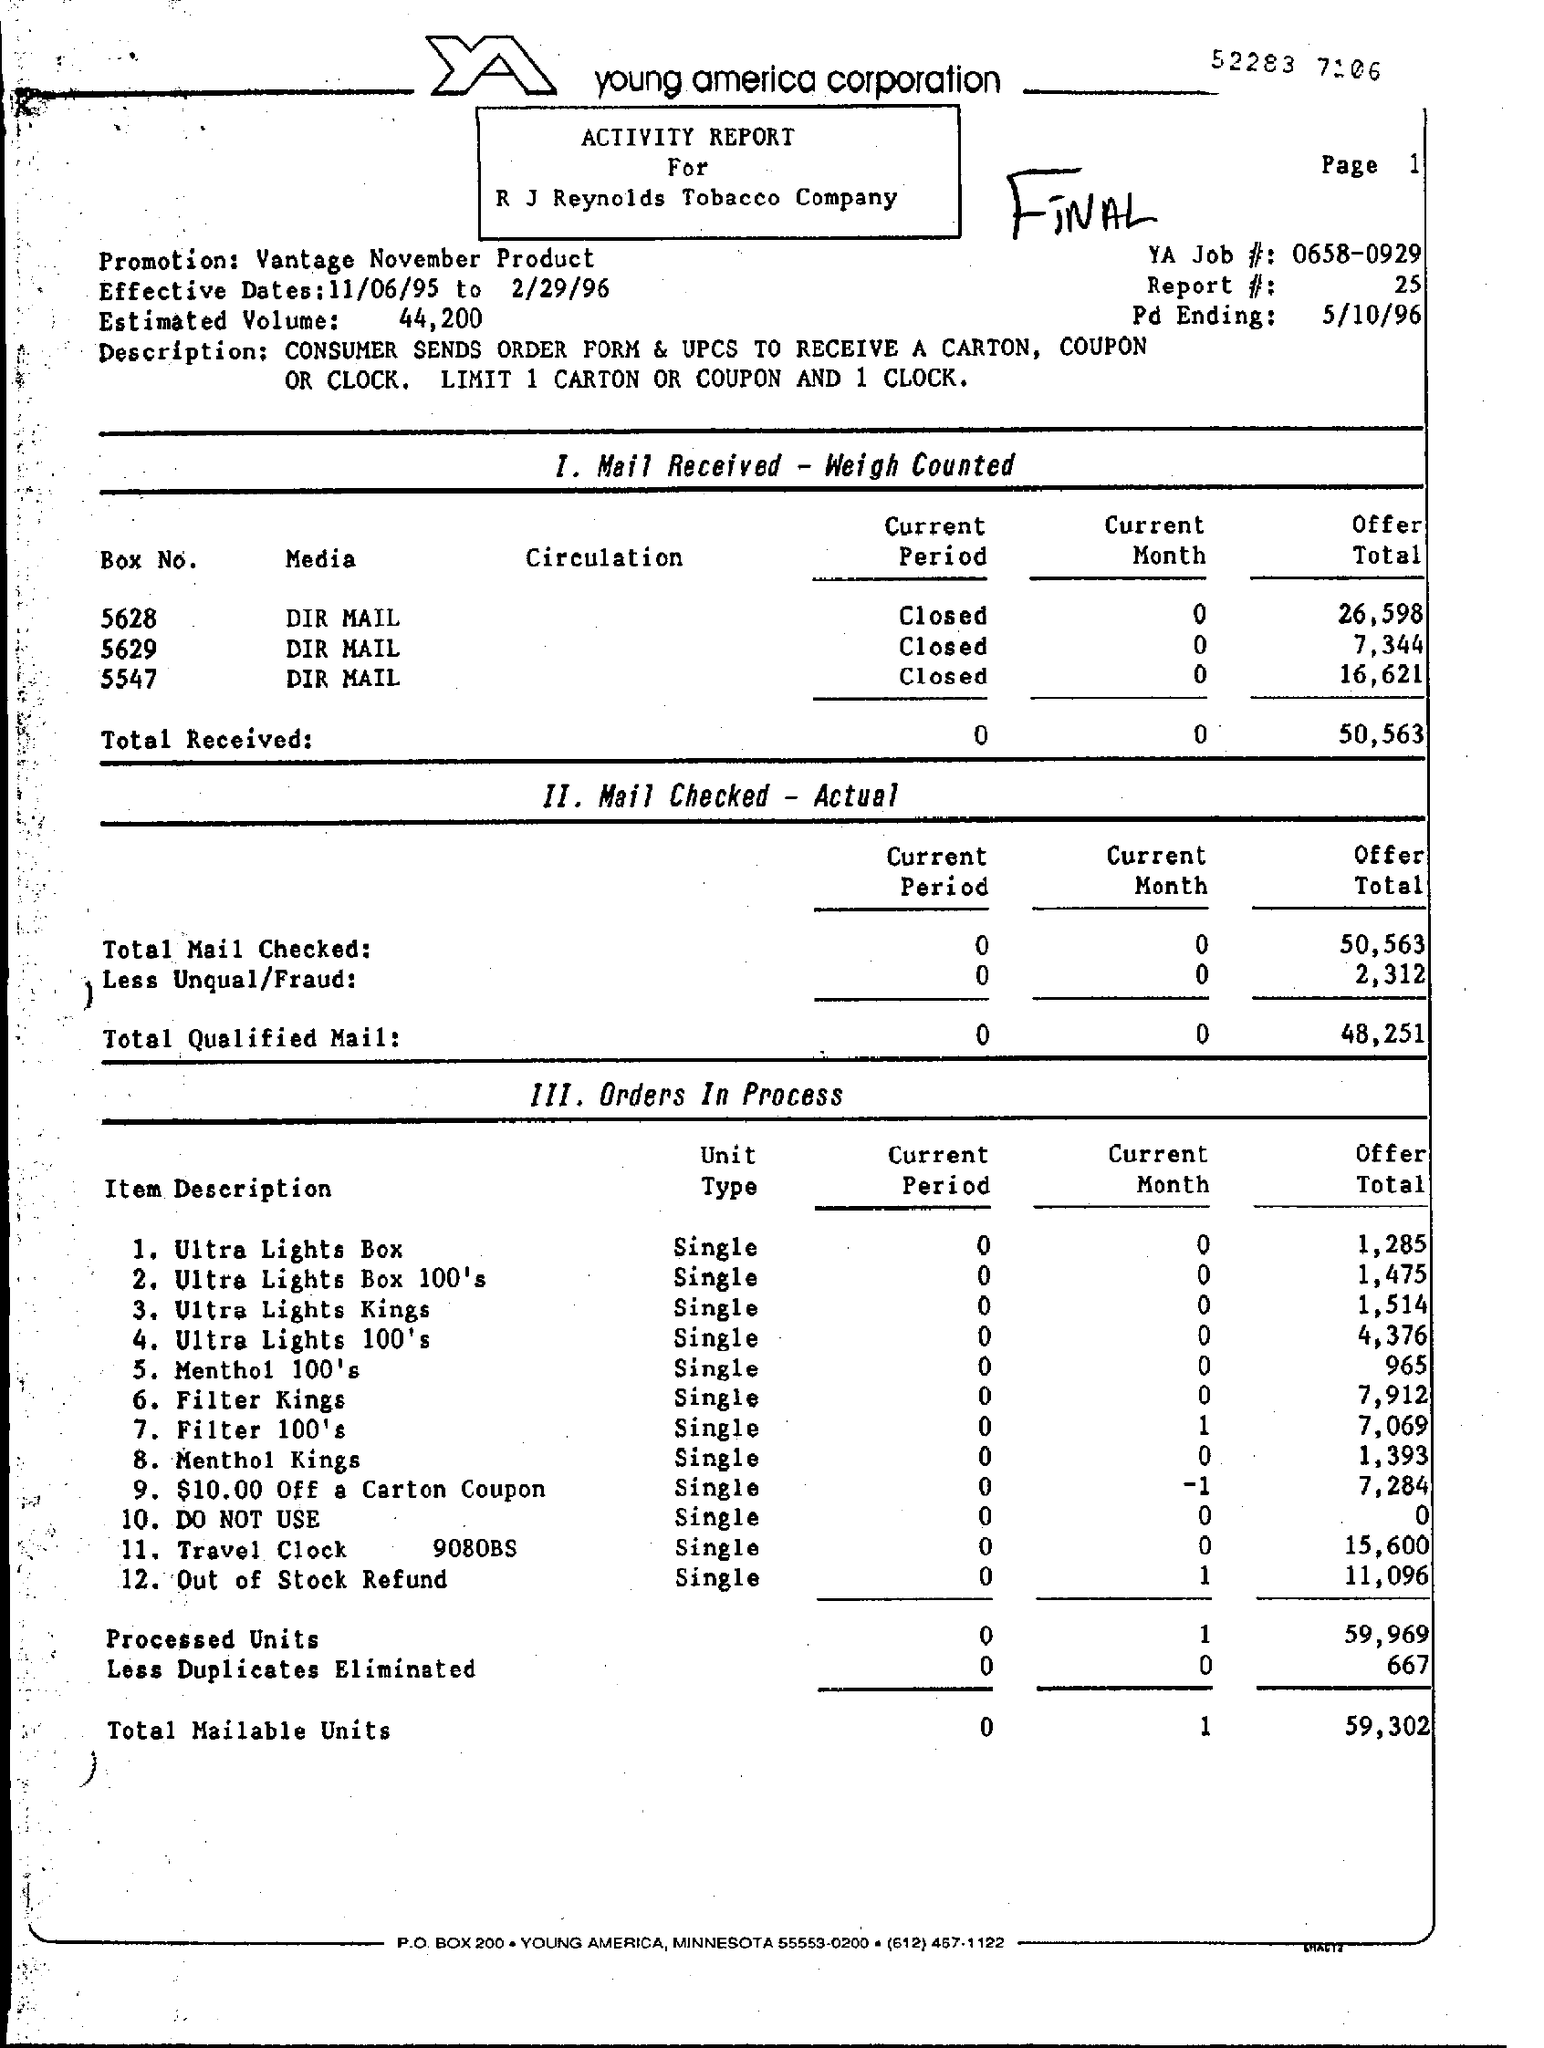Draw attention to some important aspects in this diagram. The 'Estimated Volume' is 44,200... 